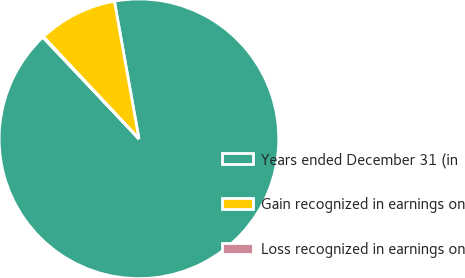Convert chart. <chart><loc_0><loc_0><loc_500><loc_500><pie_chart><fcel>Years ended December 31 (in<fcel>Gain recognized in earnings on<fcel>Loss recognized in earnings on<nl><fcel>90.75%<fcel>9.16%<fcel>0.09%<nl></chart> 